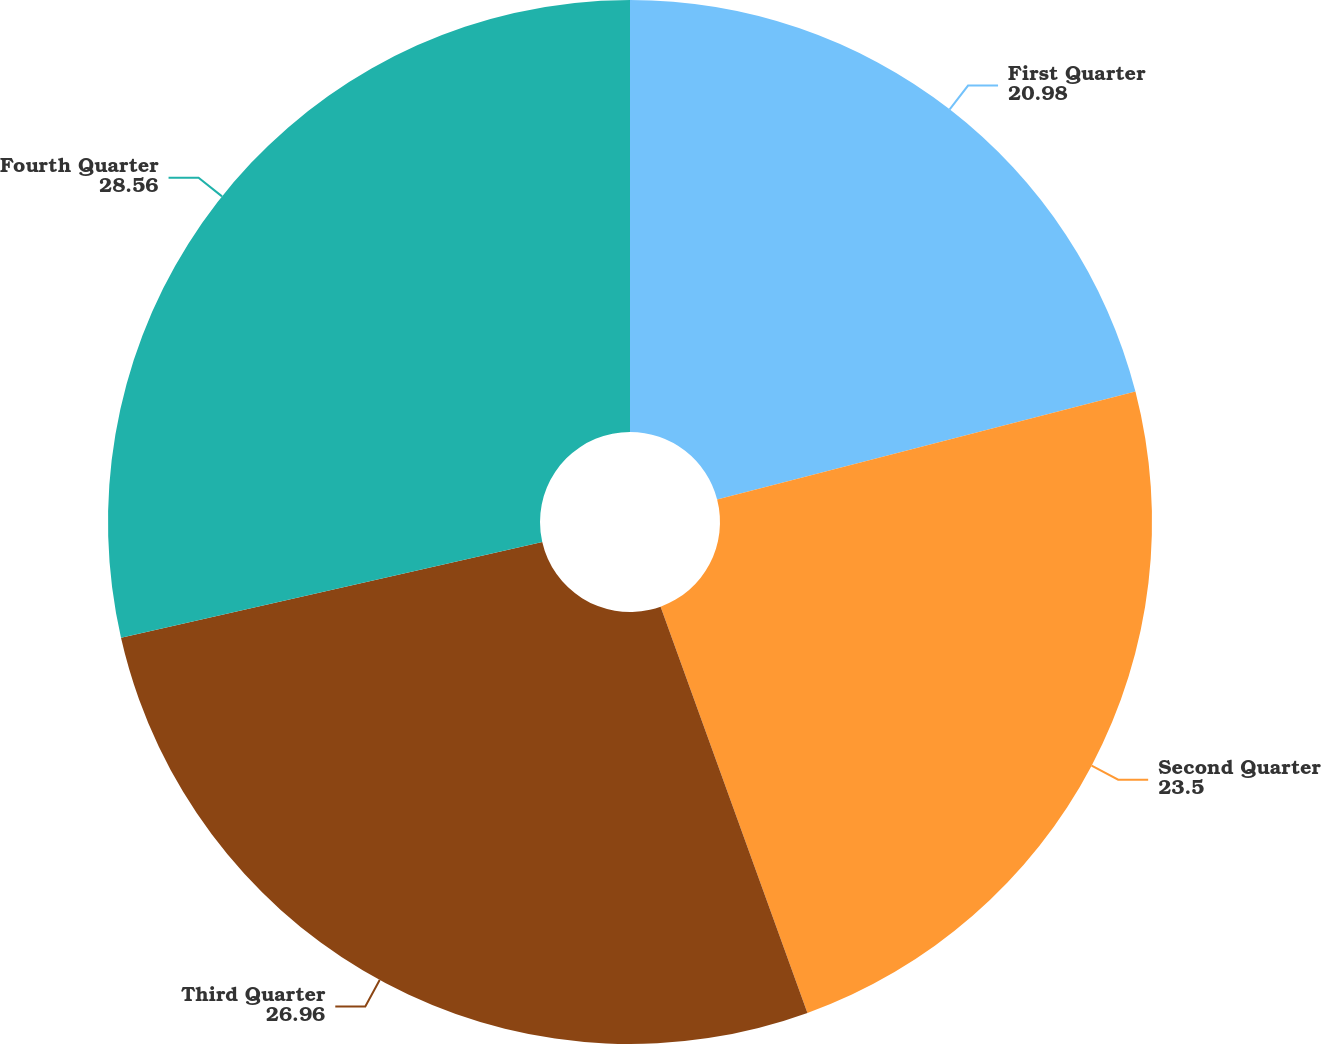Convert chart to OTSL. <chart><loc_0><loc_0><loc_500><loc_500><pie_chart><fcel>First Quarter<fcel>Second Quarter<fcel>Third Quarter<fcel>Fourth Quarter<nl><fcel>20.98%<fcel>23.5%<fcel>26.96%<fcel>28.56%<nl></chart> 